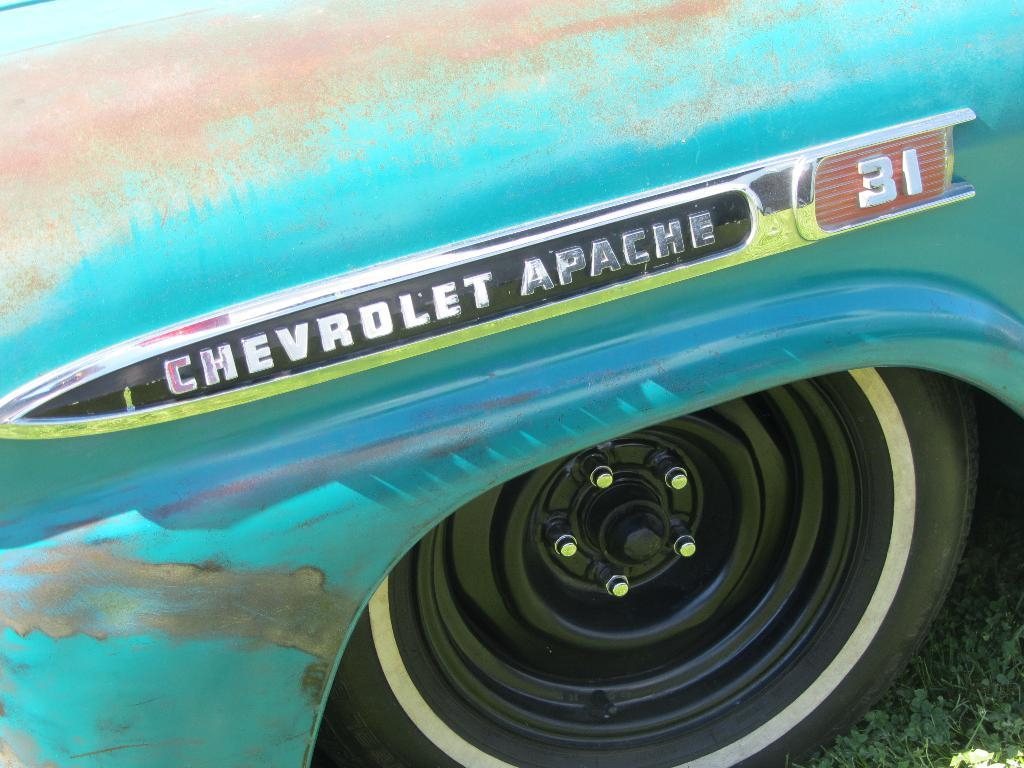What is the main subject of the image? The main subject of the image is a wheel of a vehicle. Where is the wheel located? The wheel is on the grass. Is there any text visible in the image? Yes, there is text visible in the image. Can you tell me how many geese are depicted in the image? There are no geese present in the image; it features a wheel of a vehicle on the grass with visible text. 